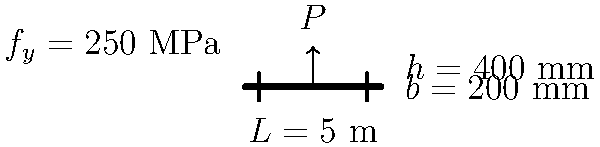As a retired industrial engineer, you're helping a friend with a home renovation project. Consider a simply supported steel beam with a span of 5 meters, subjected to a point load $P$ at its center. The beam has a rectangular cross-section with a width of 200 mm and a height of 400 mm. Given that the yield strength of the steel is 250 MPa, calculate the maximum allowable point load $P$ that can be safely applied to the beam. Let's approach this step-by-step:

1) First, we need to calculate the section modulus $(S)$ of the beam:
   $S = \frac{bh^2}{6} = \frac{200 \times 400^2}{6} = 5.33 \times 10^6$ mm³

2) The maximum bending moment $(M_{max})$ occurs at the center of the beam and is given by:
   $M_{max} = \frac{PL}{4}$, where $L$ is the span length

3) The maximum stress $(\sigma_{max})$ in the beam should not exceed the yield strength $(f_y)$:
   $\sigma_{max} = \frac{M_{max}}{S} \leq f_y$

4) Substituting the expressions:
   $\frac{PL}{4S} \leq f_y$

5) Solving for $P$:
   $P \leq \frac{4Sf_y}{L}$

6) Now, let's substitute the values:
   $P \leq \frac{4 \times (5.33 \times 10^6) \times 250}{5000}$

7) Calculating:
   $P \leq 1,066,000$ N or 1,066 kN

Therefore, the maximum allowable point load that can be safely applied to the beam is 1,066 kN.
Answer: 1,066 kN 